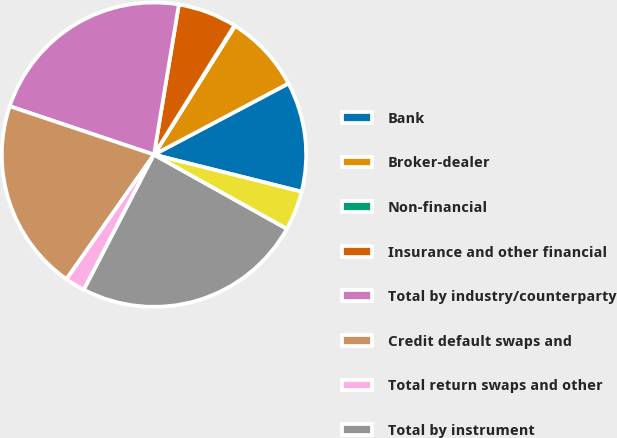Convert chart. <chart><loc_0><loc_0><loc_500><loc_500><pie_chart><fcel>Bank<fcel>Broker-dealer<fcel>Non-financial<fcel>Insurance and other financial<fcel>Total by industry/counterparty<fcel>Credit default swaps and<fcel>Total return swaps and other<fcel>Total by instrument<fcel>Monoline<nl><fcel>11.66%<fcel>8.31%<fcel>0.08%<fcel>6.25%<fcel>22.46%<fcel>20.4%<fcel>2.13%<fcel>24.52%<fcel>4.19%<nl></chart> 